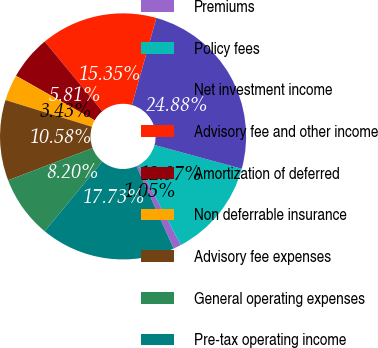Convert chart. <chart><loc_0><loc_0><loc_500><loc_500><pie_chart><fcel>Premiums<fcel>Policy fees<fcel>Net investment income<fcel>Advisory fee and other income<fcel>Amortization of deferred<fcel>Non deferrable insurance<fcel>Advisory fee expenses<fcel>General operating expenses<fcel>Pre-tax operating income<nl><fcel>1.05%<fcel>12.97%<fcel>24.88%<fcel>15.35%<fcel>5.81%<fcel>3.43%<fcel>10.58%<fcel>8.2%<fcel>17.73%<nl></chart> 